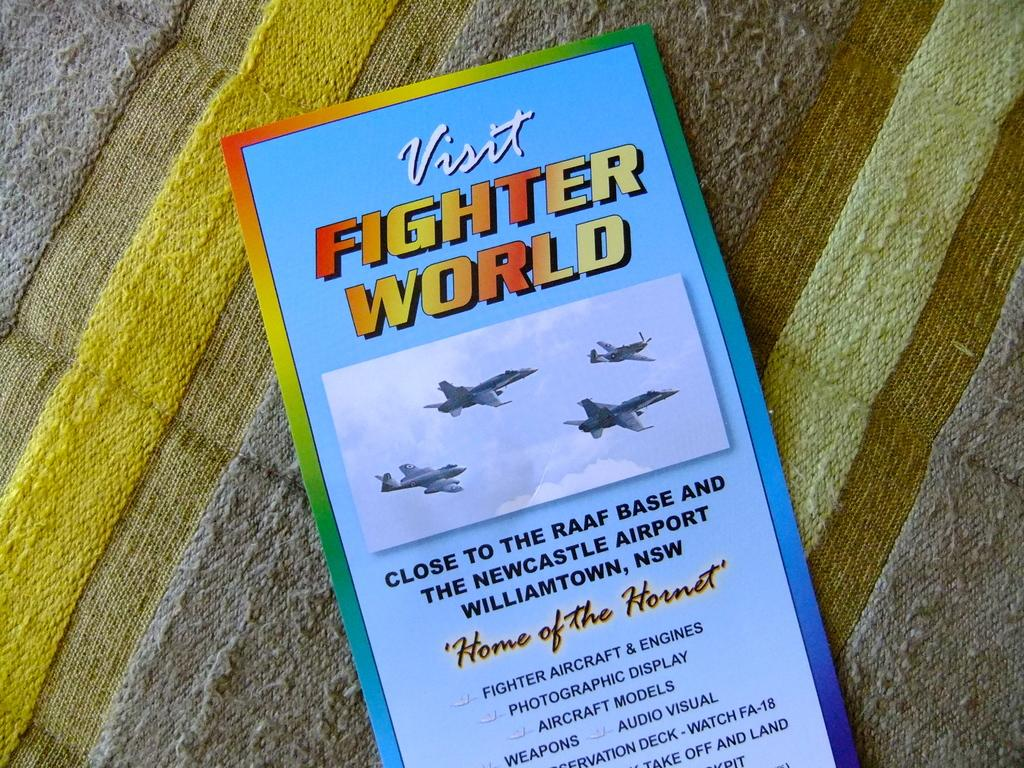<image>
Summarize the visual content of the image. A brochure or pamphlet that reads Visit FIGHTER WORLD. 